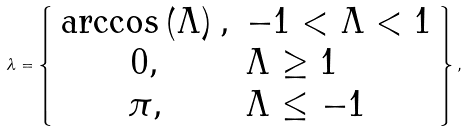Convert formula to latex. <formula><loc_0><loc_0><loc_500><loc_500>\lambda = \left \{ \begin{array} { c l } \arccos \left ( \Lambda \right ) , & - 1 < \Lambda < 1 \\ 0 , & \Lambda \geq 1 \\ \pi , & \Lambda \leq - 1 \end{array} \right \} ,</formula> 